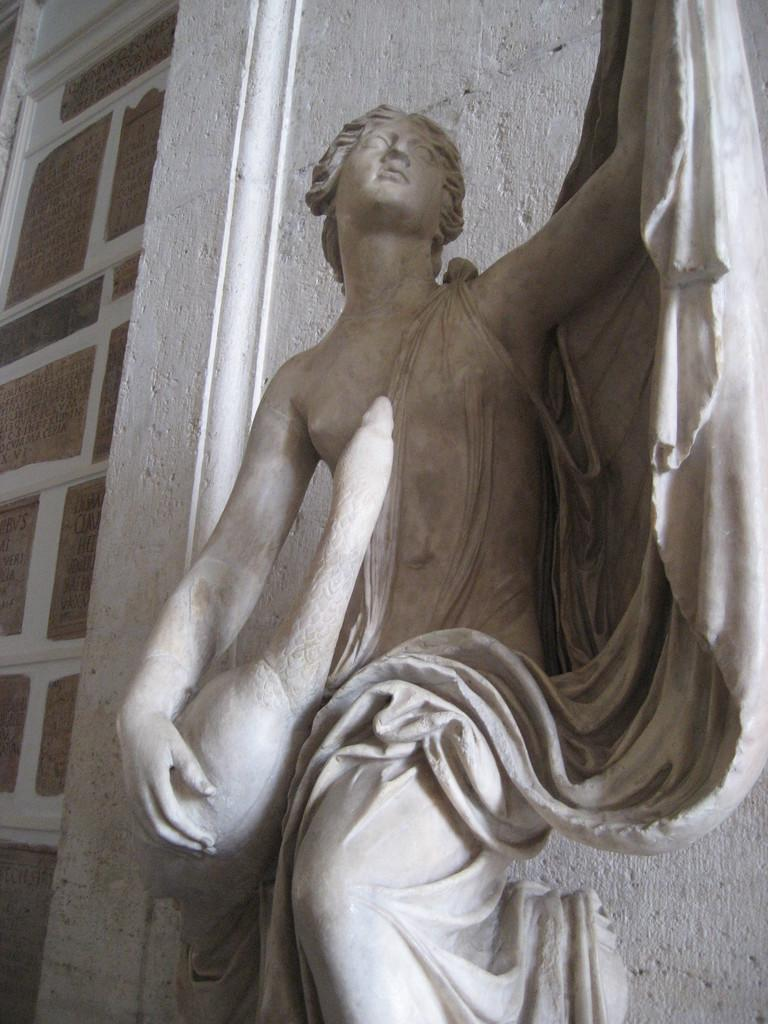What is the main subject in the image? There is a sculpture in the image. Where is the sculpture located in relation to other elements in the image? The sculpture is in front of a wall. What type of disease is affecting the wood in the image? There is no wood or disease present in the image; it features a sculpture in front of a wall. 